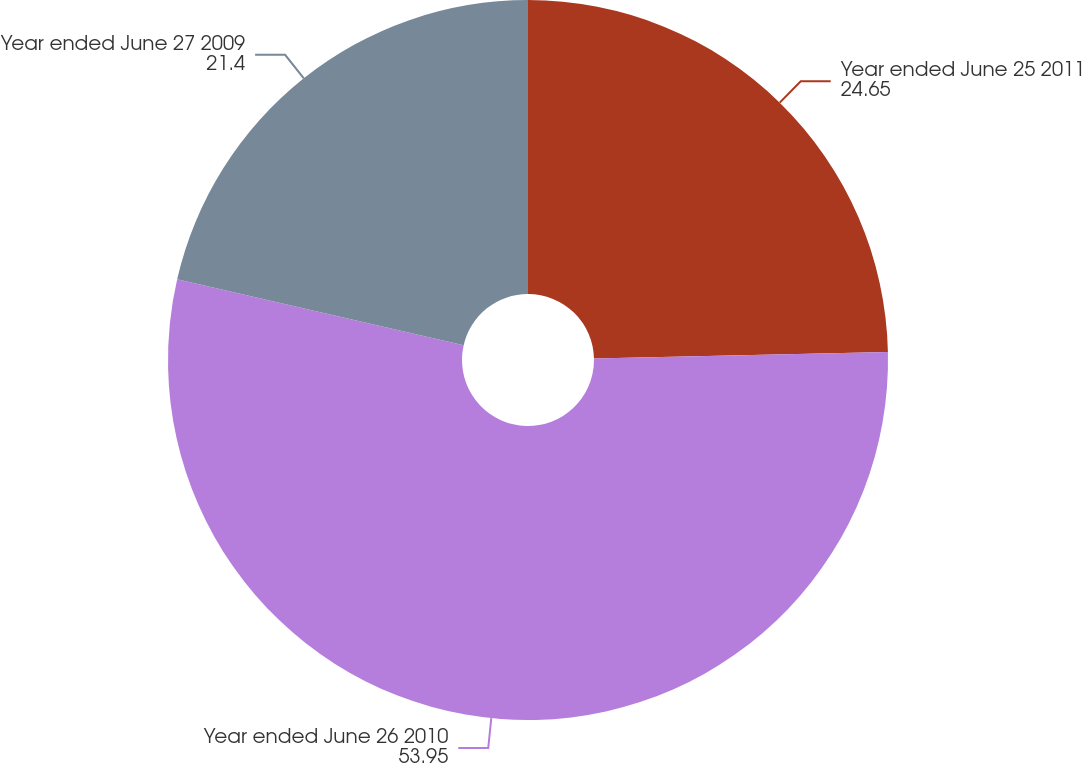<chart> <loc_0><loc_0><loc_500><loc_500><pie_chart><fcel>Year ended June 25 2011<fcel>Year ended June 26 2010<fcel>Year ended June 27 2009<nl><fcel>24.65%<fcel>53.95%<fcel>21.4%<nl></chart> 